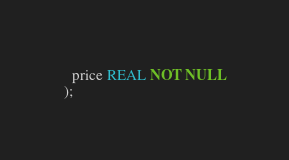<code> <loc_0><loc_0><loc_500><loc_500><_SQL_>  price REAL NOT NULL
);</code> 